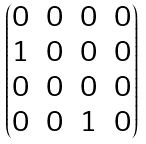Convert formula to latex. <formula><loc_0><loc_0><loc_500><loc_500>\begin{pmatrix} 0 & 0 & 0 & 0 \\ 1 & 0 & 0 & 0 \\ 0 & 0 & 0 & 0 \\ 0 & 0 & 1 & 0 \end{pmatrix}</formula> 